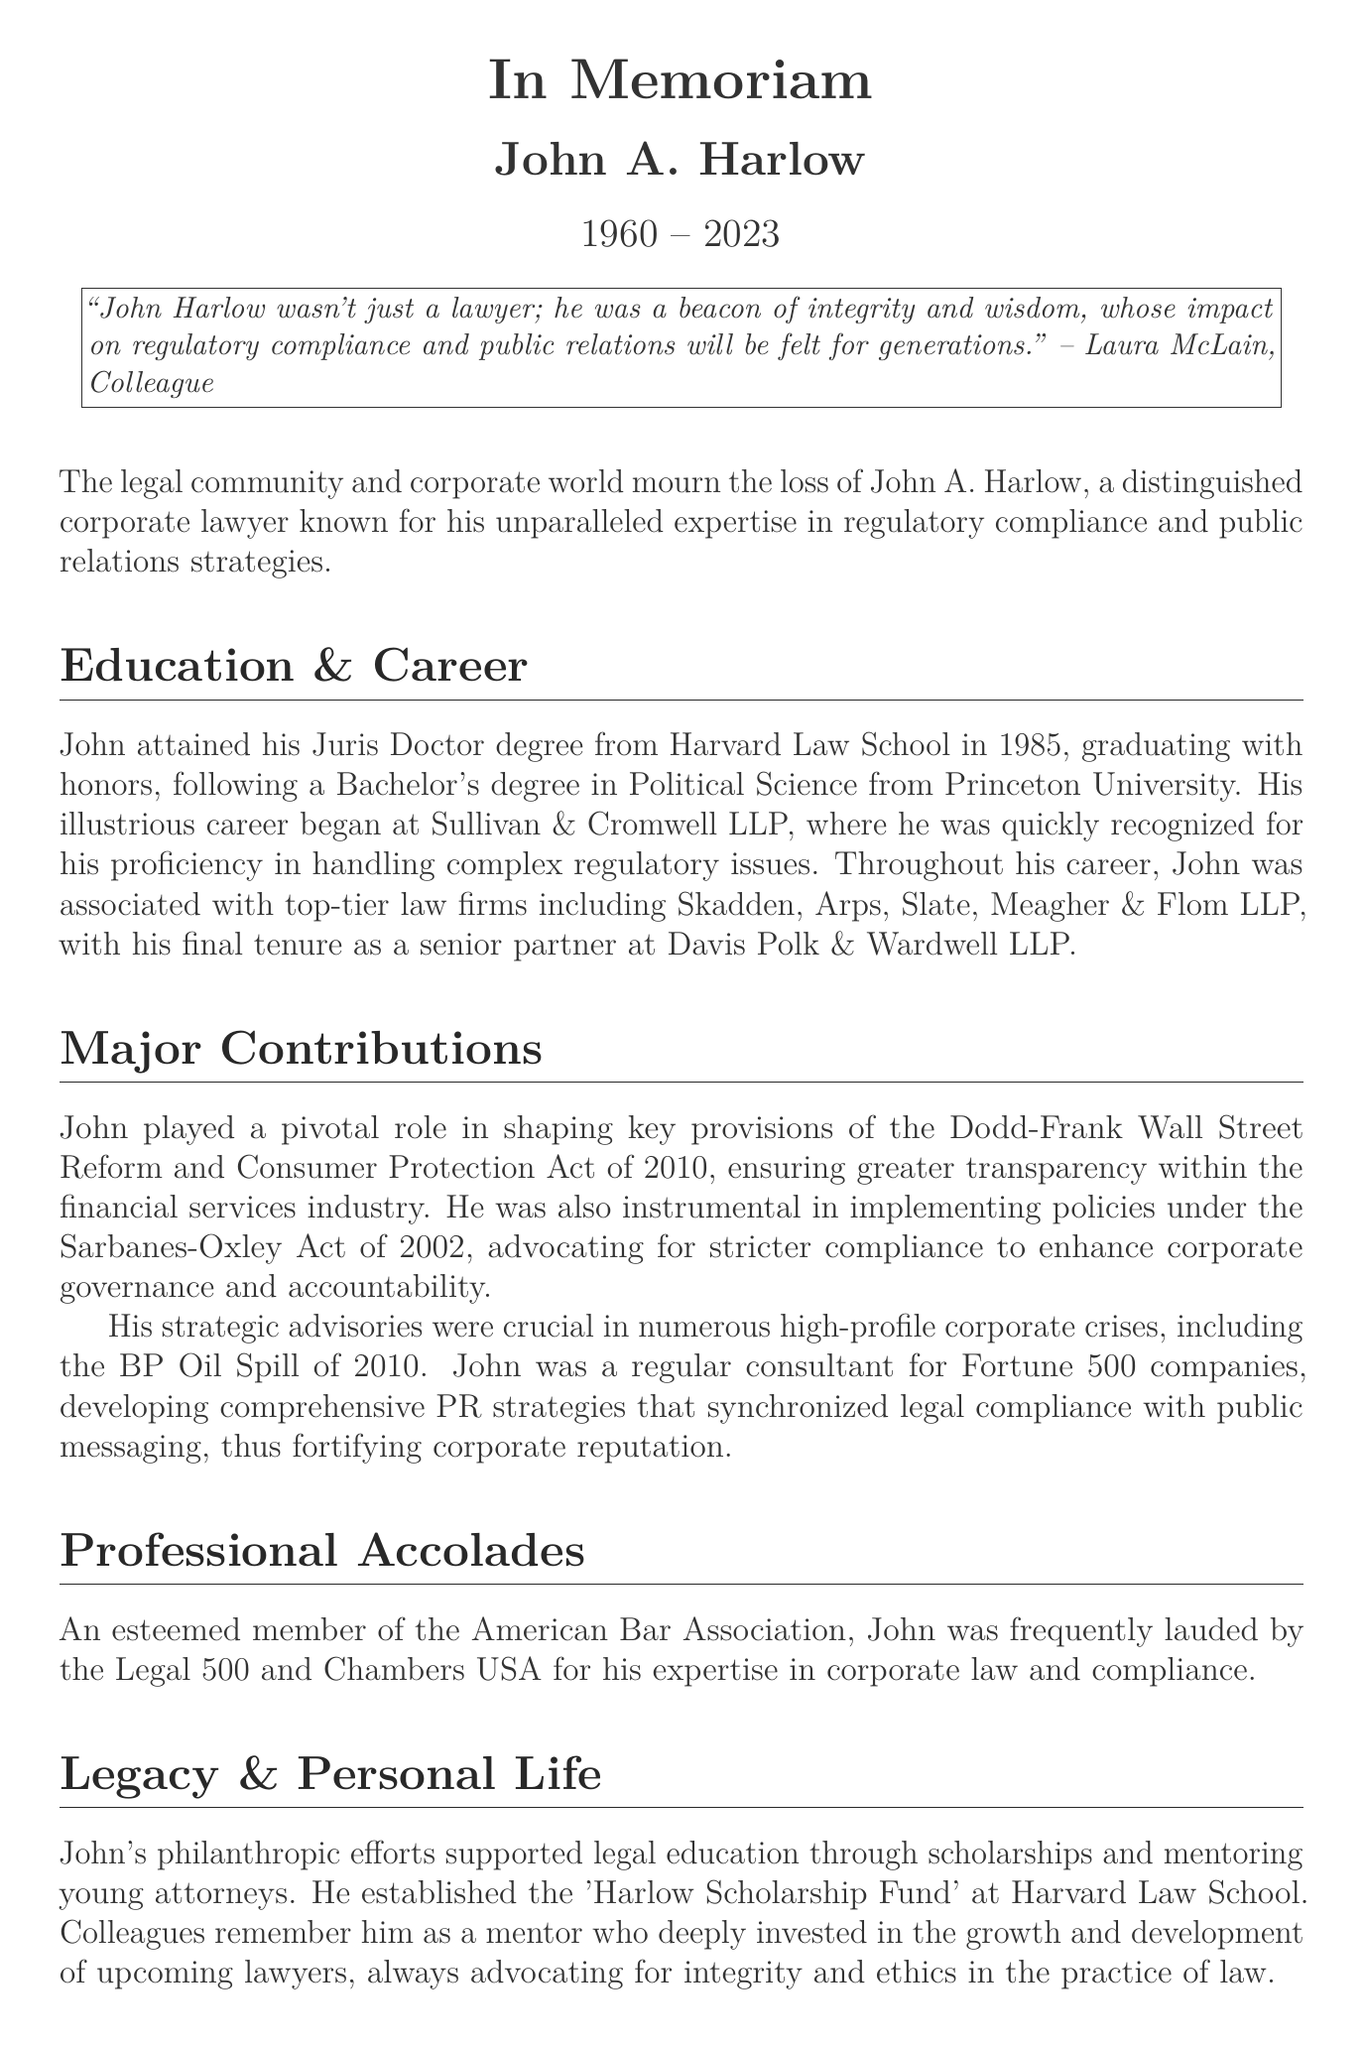What is the full name of the attorney? The document states the full name of the attorney as John A. Harlow.
Answer: John A. Harlow What year did John graduate from Harvard Law School? According to the document, John graduated from Harvard Law School in 1985.
Answer: 1985 What major legislation did John impact? The obituary mentions that John played a pivotal role in the Dodd-Frank Wall Street Reform and Consumer Protection Act of 2010.
Answer: Dodd-Frank Wall Street Reform and Consumer Protection Act Who did John work for at the beginning of his career? The document indicates that John began his career at Sullivan & Cromwell LLP.
Answer: Sullivan & Cromwell LLP What did John establish at Harvard Law School? The obituary notes that John established the 'Harlow Scholarship Fund' at Harvard Law School.
Answer: Harlow Scholarship Fund How many children did John have? The document states that John had two children, Michael and Sarah.
Answer: Two What was John’s approach during corporate crises? John developed comprehensive PR strategies that synchronized legal compliance with public messaging.
Answer: PR strategies that synchronized legal compliance with public messaging What type of lawyer was John A. Harlow described as? The document describes him as a distinguished corporate lawyer.
Answer: Distinguished corporate lawyer What is the name of John’s wife? According to the document, John is survived by his wife, Eleanor.
Answer: Eleanor 